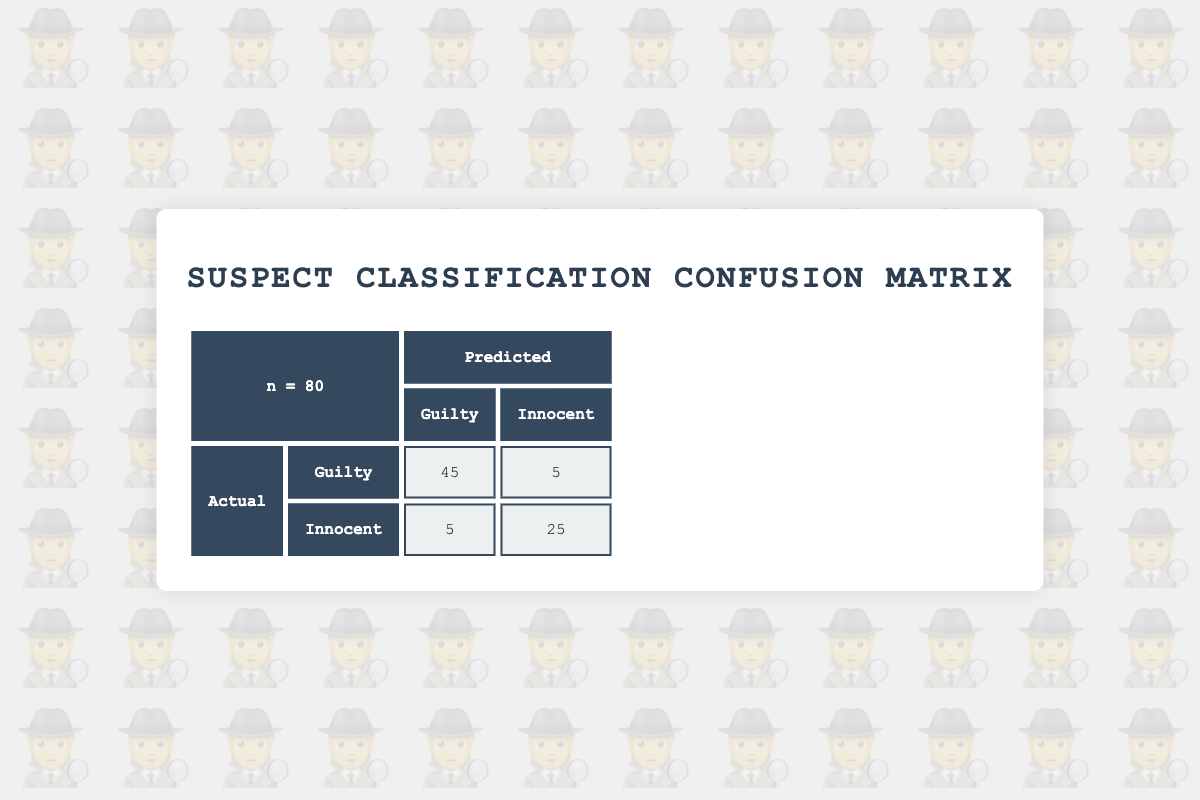What is the total number of suspects classified as guilty? The confusion matrix indicates that there are 50 actual guilty suspects. This number represents the total count of individuals whose true status is guilty.
Answer: 50 How many suspects were correctly identified as guilty? The true positive count in the confusion matrix shows that 45 suspects were accurately identified as guilty. This means that the prediction matched the actual status for these individuals.
Answer: 45 What is the total number of innocent suspects? The confusion matrix states that there are 30 actual innocent suspects, which means they are not guilty. This value represents the total for those whose true status is innocent.
Answer: 30 How many innocent suspects were mistakenly classified as guilty? The confusion matrix indicates that there are 5 false positives, meaning 5 innocent suspects were incorrectly predicted to be guilty. This is a measure of error in the classification for the innocent group.
Answer: 5 What is the sum of true positive and true negative values? To find the sum, add the true positives (45) and true negatives (25) together: 45 + 25 = 70. This total represents how many suspects were correctly classified overall.
Answer: 70 Was Aaron King correctly classified based on his alibi? Aaron King has an actual status of innocent but was predicted to be guilty. Since the prediction does not match the actual status, he was not correctly classified.
Answer: No What percentage of the innocent suspects were accurately identified? There are 30 innocent suspects in total, and 25 were correctly classified as innocent (true negatives). To find the percentage, divide 25 by 30 and multiply by 100, resulting in approximately 83.33%.
Answer: 83.33% How many total misclassifications occurred? To find the total misclassifications, add the false negatives (5) and false positives (5): 5 + 5 = 10. This indicates the total number of suspects that were incorrectly classified.
Answer: 10 What is the ratio of true positives to false negatives? The number of true positives is 45 while the number of false negatives is 5. To find the ratio, divide 45 by 5, resulting in a ratio of 9:1. This demonstrates a strong ability to correctly identify guilty suspects compared to misclassifications.
Answer: 9:1 